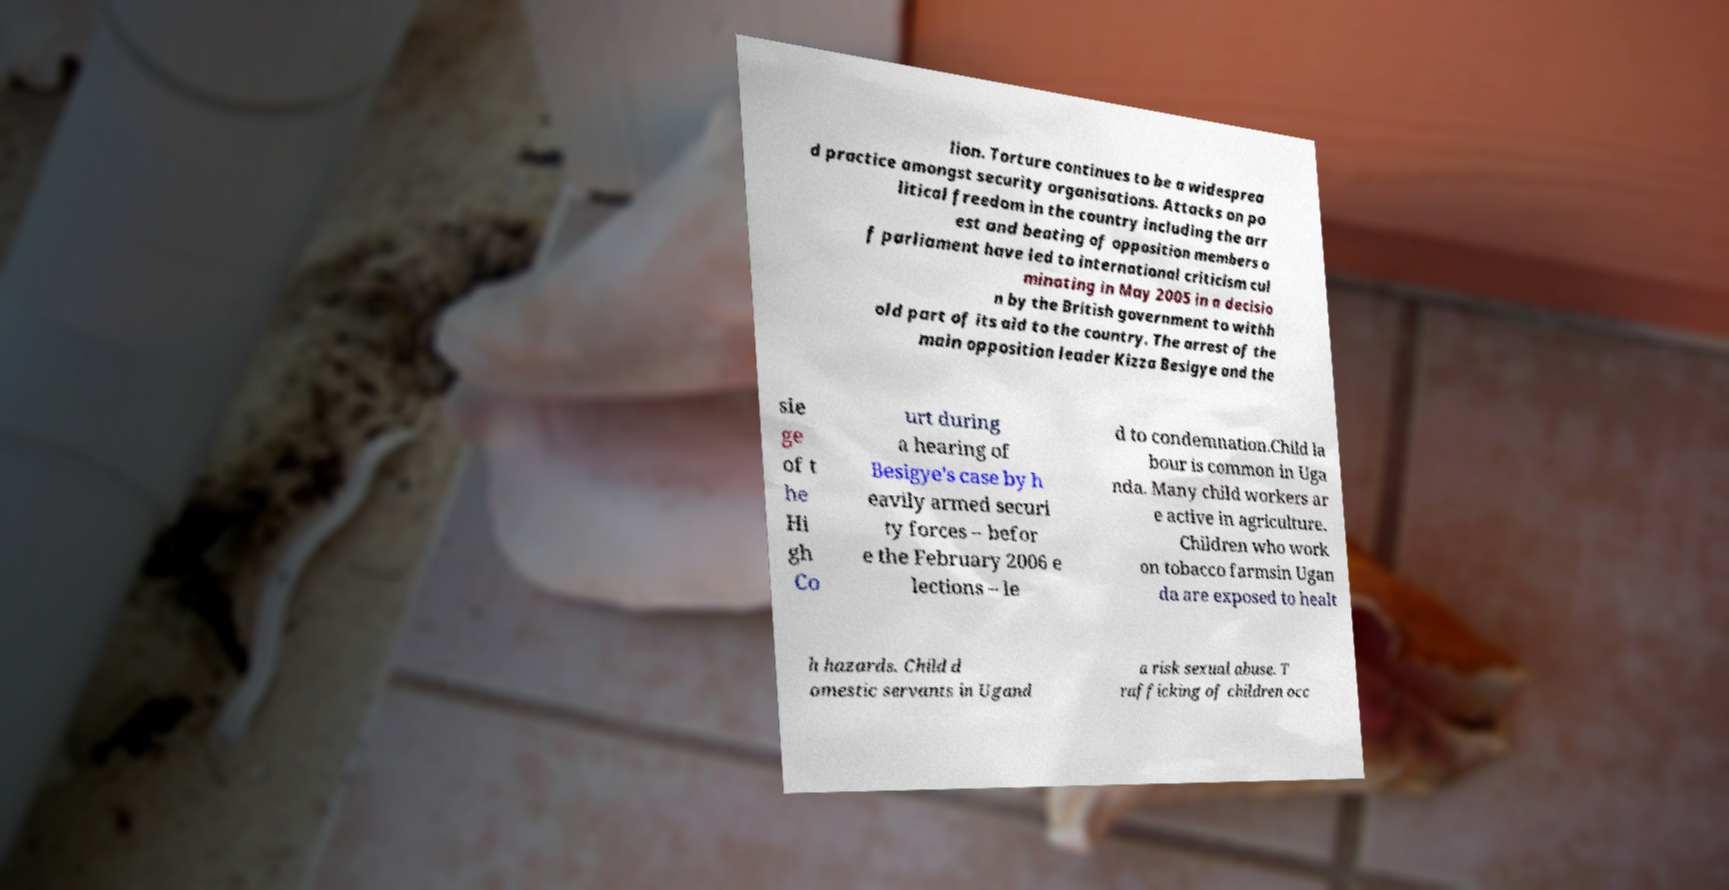There's text embedded in this image that I need extracted. Can you transcribe it verbatim? lion. Torture continues to be a widesprea d practice amongst security organisations. Attacks on po litical freedom in the country including the arr est and beating of opposition members o f parliament have led to international criticism cul minating in May 2005 in a decisio n by the British government to withh old part of its aid to the country. The arrest of the main opposition leader Kizza Besigye and the sie ge of t he Hi gh Co urt during a hearing of Besigye's case by h eavily armed securi ty forces – befor e the February 2006 e lections – le d to condemnation.Child la bour is common in Uga nda. Many child workers ar e active in agriculture. Children who work on tobacco farmsin Ugan da are exposed to healt h hazards. Child d omestic servants in Ugand a risk sexual abuse. T rafficking of children occ 